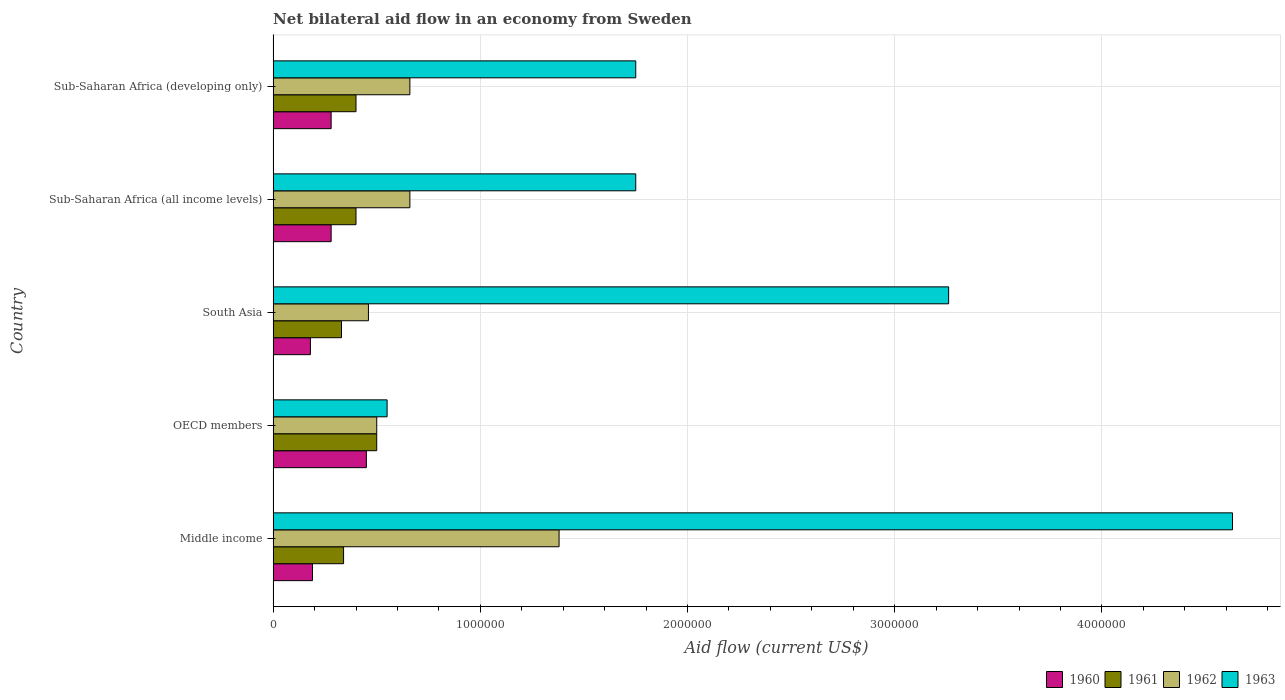Are the number of bars per tick equal to the number of legend labels?
Your response must be concise. Yes. Are the number of bars on each tick of the Y-axis equal?
Give a very brief answer. Yes. How many bars are there on the 2nd tick from the top?
Make the answer very short. 4. How many bars are there on the 2nd tick from the bottom?
Offer a terse response. 4. What is the label of the 3rd group of bars from the top?
Provide a short and direct response. South Asia. In how many cases, is the number of bars for a given country not equal to the number of legend labels?
Offer a very short reply. 0. What is the total net bilateral aid flow in 1962 in the graph?
Provide a short and direct response. 3.66e+06. What is the difference between the net bilateral aid flow in 1962 in South Asia and that in Sub-Saharan Africa (developing only)?
Provide a succinct answer. -2.00e+05. What is the difference between the net bilateral aid flow in 1963 in Sub-Saharan Africa (all income levels) and the net bilateral aid flow in 1960 in South Asia?
Provide a short and direct response. 1.57e+06. What is the average net bilateral aid flow in 1963 per country?
Provide a succinct answer. 2.39e+06. What is the difference between the net bilateral aid flow in 1960 and net bilateral aid flow in 1963 in South Asia?
Provide a succinct answer. -3.08e+06. What is the ratio of the net bilateral aid flow in 1962 in South Asia to that in Sub-Saharan Africa (developing only)?
Provide a succinct answer. 0.7. Is the net bilateral aid flow in 1963 in South Asia less than that in Sub-Saharan Africa (all income levels)?
Offer a very short reply. No. Is the difference between the net bilateral aid flow in 1960 in Sub-Saharan Africa (all income levels) and Sub-Saharan Africa (developing only) greater than the difference between the net bilateral aid flow in 1963 in Sub-Saharan Africa (all income levels) and Sub-Saharan Africa (developing only)?
Make the answer very short. No. What is the difference between the highest and the second highest net bilateral aid flow in 1961?
Offer a terse response. 1.00e+05. Is the sum of the net bilateral aid flow in 1962 in Sub-Saharan Africa (all income levels) and Sub-Saharan Africa (developing only) greater than the maximum net bilateral aid flow in 1960 across all countries?
Offer a terse response. Yes. Is it the case that in every country, the sum of the net bilateral aid flow in 1962 and net bilateral aid flow in 1960 is greater than the sum of net bilateral aid flow in 1961 and net bilateral aid flow in 1963?
Make the answer very short. No. What does the 3rd bar from the bottom in OECD members represents?
Your response must be concise. 1962. Is it the case that in every country, the sum of the net bilateral aid flow in 1960 and net bilateral aid flow in 1962 is greater than the net bilateral aid flow in 1961?
Provide a short and direct response. Yes. Are all the bars in the graph horizontal?
Your response must be concise. Yes. What is the difference between two consecutive major ticks on the X-axis?
Your answer should be very brief. 1.00e+06. Are the values on the major ticks of X-axis written in scientific E-notation?
Keep it short and to the point. No. Does the graph contain any zero values?
Ensure brevity in your answer.  No. Where does the legend appear in the graph?
Ensure brevity in your answer.  Bottom right. What is the title of the graph?
Provide a succinct answer. Net bilateral aid flow in an economy from Sweden. Does "1985" appear as one of the legend labels in the graph?
Provide a succinct answer. No. What is the label or title of the Y-axis?
Your answer should be very brief. Country. What is the Aid flow (current US$) of 1962 in Middle income?
Provide a short and direct response. 1.38e+06. What is the Aid flow (current US$) in 1963 in Middle income?
Offer a very short reply. 4.63e+06. What is the Aid flow (current US$) in 1962 in OECD members?
Keep it short and to the point. 5.00e+05. What is the Aid flow (current US$) in 1963 in South Asia?
Offer a very short reply. 3.26e+06. What is the Aid flow (current US$) of 1961 in Sub-Saharan Africa (all income levels)?
Your answer should be very brief. 4.00e+05. What is the Aid flow (current US$) in 1962 in Sub-Saharan Africa (all income levels)?
Keep it short and to the point. 6.60e+05. What is the Aid flow (current US$) of 1963 in Sub-Saharan Africa (all income levels)?
Provide a short and direct response. 1.75e+06. What is the Aid flow (current US$) in 1960 in Sub-Saharan Africa (developing only)?
Your answer should be very brief. 2.80e+05. What is the Aid flow (current US$) of 1961 in Sub-Saharan Africa (developing only)?
Provide a succinct answer. 4.00e+05. What is the Aid flow (current US$) in 1963 in Sub-Saharan Africa (developing only)?
Provide a succinct answer. 1.75e+06. Across all countries, what is the maximum Aid flow (current US$) in 1962?
Provide a succinct answer. 1.38e+06. Across all countries, what is the maximum Aid flow (current US$) in 1963?
Your answer should be compact. 4.63e+06. Across all countries, what is the minimum Aid flow (current US$) of 1961?
Make the answer very short. 3.30e+05. Across all countries, what is the minimum Aid flow (current US$) of 1962?
Your answer should be compact. 4.60e+05. Across all countries, what is the minimum Aid flow (current US$) in 1963?
Provide a short and direct response. 5.50e+05. What is the total Aid flow (current US$) of 1960 in the graph?
Ensure brevity in your answer.  1.38e+06. What is the total Aid flow (current US$) in 1961 in the graph?
Offer a terse response. 1.97e+06. What is the total Aid flow (current US$) of 1962 in the graph?
Provide a succinct answer. 3.66e+06. What is the total Aid flow (current US$) of 1963 in the graph?
Give a very brief answer. 1.19e+07. What is the difference between the Aid flow (current US$) in 1960 in Middle income and that in OECD members?
Offer a very short reply. -2.60e+05. What is the difference between the Aid flow (current US$) in 1962 in Middle income and that in OECD members?
Provide a short and direct response. 8.80e+05. What is the difference between the Aid flow (current US$) of 1963 in Middle income and that in OECD members?
Offer a terse response. 4.08e+06. What is the difference between the Aid flow (current US$) of 1960 in Middle income and that in South Asia?
Make the answer very short. 10000. What is the difference between the Aid flow (current US$) in 1962 in Middle income and that in South Asia?
Provide a succinct answer. 9.20e+05. What is the difference between the Aid flow (current US$) in 1963 in Middle income and that in South Asia?
Your answer should be very brief. 1.37e+06. What is the difference between the Aid flow (current US$) of 1960 in Middle income and that in Sub-Saharan Africa (all income levels)?
Your answer should be very brief. -9.00e+04. What is the difference between the Aid flow (current US$) in 1962 in Middle income and that in Sub-Saharan Africa (all income levels)?
Your answer should be very brief. 7.20e+05. What is the difference between the Aid flow (current US$) in 1963 in Middle income and that in Sub-Saharan Africa (all income levels)?
Your answer should be compact. 2.88e+06. What is the difference between the Aid flow (current US$) of 1961 in Middle income and that in Sub-Saharan Africa (developing only)?
Offer a terse response. -6.00e+04. What is the difference between the Aid flow (current US$) of 1962 in Middle income and that in Sub-Saharan Africa (developing only)?
Offer a very short reply. 7.20e+05. What is the difference between the Aid flow (current US$) in 1963 in Middle income and that in Sub-Saharan Africa (developing only)?
Provide a short and direct response. 2.88e+06. What is the difference between the Aid flow (current US$) in 1963 in OECD members and that in South Asia?
Offer a terse response. -2.71e+06. What is the difference between the Aid flow (current US$) of 1960 in OECD members and that in Sub-Saharan Africa (all income levels)?
Your response must be concise. 1.70e+05. What is the difference between the Aid flow (current US$) in 1962 in OECD members and that in Sub-Saharan Africa (all income levels)?
Your answer should be very brief. -1.60e+05. What is the difference between the Aid flow (current US$) in 1963 in OECD members and that in Sub-Saharan Africa (all income levels)?
Provide a short and direct response. -1.20e+06. What is the difference between the Aid flow (current US$) of 1961 in OECD members and that in Sub-Saharan Africa (developing only)?
Your answer should be very brief. 1.00e+05. What is the difference between the Aid flow (current US$) of 1962 in OECD members and that in Sub-Saharan Africa (developing only)?
Your answer should be very brief. -1.60e+05. What is the difference between the Aid flow (current US$) of 1963 in OECD members and that in Sub-Saharan Africa (developing only)?
Offer a terse response. -1.20e+06. What is the difference between the Aid flow (current US$) in 1960 in South Asia and that in Sub-Saharan Africa (all income levels)?
Your answer should be very brief. -1.00e+05. What is the difference between the Aid flow (current US$) of 1961 in South Asia and that in Sub-Saharan Africa (all income levels)?
Give a very brief answer. -7.00e+04. What is the difference between the Aid flow (current US$) of 1962 in South Asia and that in Sub-Saharan Africa (all income levels)?
Give a very brief answer. -2.00e+05. What is the difference between the Aid flow (current US$) of 1963 in South Asia and that in Sub-Saharan Africa (all income levels)?
Make the answer very short. 1.51e+06. What is the difference between the Aid flow (current US$) in 1961 in South Asia and that in Sub-Saharan Africa (developing only)?
Offer a very short reply. -7.00e+04. What is the difference between the Aid flow (current US$) of 1962 in South Asia and that in Sub-Saharan Africa (developing only)?
Provide a succinct answer. -2.00e+05. What is the difference between the Aid flow (current US$) of 1963 in South Asia and that in Sub-Saharan Africa (developing only)?
Provide a short and direct response. 1.51e+06. What is the difference between the Aid flow (current US$) in 1962 in Sub-Saharan Africa (all income levels) and that in Sub-Saharan Africa (developing only)?
Your response must be concise. 0. What is the difference between the Aid flow (current US$) in 1960 in Middle income and the Aid flow (current US$) in 1961 in OECD members?
Give a very brief answer. -3.10e+05. What is the difference between the Aid flow (current US$) of 1960 in Middle income and the Aid flow (current US$) of 1962 in OECD members?
Provide a short and direct response. -3.10e+05. What is the difference between the Aid flow (current US$) in 1960 in Middle income and the Aid flow (current US$) in 1963 in OECD members?
Your answer should be compact. -3.60e+05. What is the difference between the Aid flow (current US$) in 1961 in Middle income and the Aid flow (current US$) in 1962 in OECD members?
Your answer should be compact. -1.60e+05. What is the difference between the Aid flow (current US$) of 1962 in Middle income and the Aid flow (current US$) of 1963 in OECD members?
Offer a very short reply. 8.30e+05. What is the difference between the Aid flow (current US$) in 1960 in Middle income and the Aid flow (current US$) in 1961 in South Asia?
Your answer should be compact. -1.40e+05. What is the difference between the Aid flow (current US$) in 1960 in Middle income and the Aid flow (current US$) in 1962 in South Asia?
Your answer should be compact. -2.70e+05. What is the difference between the Aid flow (current US$) of 1960 in Middle income and the Aid flow (current US$) of 1963 in South Asia?
Provide a succinct answer. -3.07e+06. What is the difference between the Aid flow (current US$) in 1961 in Middle income and the Aid flow (current US$) in 1962 in South Asia?
Give a very brief answer. -1.20e+05. What is the difference between the Aid flow (current US$) in 1961 in Middle income and the Aid flow (current US$) in 1963 in South Asia?
Your answer should be compact. -2.92e+06. What is the difference between the Aid flow (current US$) in 1962 in Middle income and the Aid flow (current US$) in 1963 in South Asia?
Make the answer very short. -1.88e+06. What is the difference between the Aid flow (current US$) in 1960 in Middle income and the Aid flow (current US$) in 1962 in Sub-Saharan Africa (all income levels)?
Ensure brevity in your answer.  -4.70e+05. What is the difference between the Aid flow (current US$) of 1960 in Middle income and the Aid flow (current US$) of 1963 in Sub-Saharan Africa (all income levels)?
Provide a short and direct response. -1.56e+06. What is the difference between the Aid flow (current US$) in 1961 in Middle income and the Aid flow (current US$) in 1962 in Sub-Saharan Africa (all income levels)?
Give a very brief answer. -3.20e+05. What is the difference between the Aid flow (current US$) in 1961 in Middle income and the Aid flow (current US$) in 1963 in Sub-Saharan Africa (all income levels)?
Ensure brevity in your answer.  -1.41e+06. What is the difference between the Aid flow (current US$) of 1962 in Middle income and the Aid flow (current US$) of 1963 in Sub-Saharan Africa (all income levels)?
Make the answer very short. -3.70e+05. What is the difference between the Aid flow (current US$) of 1960 in Middle income and the Aid flow (current US$) of 1962 in Sub-Saharan Africa (developing only)?
Your answer should be very brief. -4.70e+05. What is the difference between the Aid flow (current US$) in 1960 in Middle income and the Aid flow (current US$) in 1963 in Sub-Saharan Africa (developing only)?
Make the answer very short. -1.56e+06. What is the difference between the Aid flow (current US$) of 1961 in Middle income and the Aid flow (current US$) of 1962 in Sub-Saharan Africa (developing only)?
Make the answer very short. -3.20e+05. What is the difference between the Aid flow (current US$) in 1961 in Middle income and the Aid flow (current US$) in 1963 in Sub-Saharan Africa (developing only)?
Provide a short and direct response. -1.41e+06. What is the difference between the Aid flow (current US$) in 1962 in Middle income and the Aid flow (current US$) in 1963 in Sub-Saharan Africa (developing only)?
Provide a short and direct response. -3.70e+05. What is the difference between the Aid flow (current US$) in 1960 in OECD members and the Aid flow (current US$) in 1963 in South Asia?
Make the answer very short. -2.81e+06. What is the difference between the Aid flow (current US$) of 1961 in OECD members and the Aid flow (current US$) of 1963 in South Asia?
Ensure brevity in your answer.  -2.76e+06. What is the difference between the Aid flow (current US$) of 1962 in OECD members and the Aid flow (current US$) of 1963 in South Asia?
Your answer should be compact. -2.76e+06. What is the difference between the Aid flow (current US$) in 1960 in OECD members and the Aid flow (current US$) in 1963 in Sub-Saharan Africa (all income levels)?
Give a very brief answer. -1.30e+06. What is the difference between the Aid flow (current US$) of 1961 in OECD members and the Aid flow (current US$) of 1962 in Sub-Saharan Africa (all income levels)?
Your answer should be compact. -1.60e+05. What is the difference between the Aid flow (current US$) of 1961 in OECD members and the Aid flow (current US$) of 1963 in Sub-Saharan Africa (all income levels)?
Make the answer very short. -1.25e+06. What is the difference between the Aid flow (current US$) of 1962 in OECD members and the Aid flow (current US$) of 1963 in Sub-Saharan Africa (all income levels)?
Provide a succinct answer. -1.25e+06. What is the difference between the Aid flow (current US$) of 1960 in OECD members and the Aid flow (current US$) of 1961 in Sub-Saharan Africa (developing only)?
Your answer should be very brief. 5.00e+04. What is the difference between the Aid flow (current US$) of 1960 in OECD members and the Aid flow (current US$) of 1963 in Sub-Saharan Africa (developing only)?
Offer a terse response. -1.30e+06. What is the difference between the Aid flow (current US$) of 1961 in OECD members and the Aid flow (current US$) of 1962 in Sub-Saharan Africa (developing only)?
Ensure brevity in your answer.  -1.60e+05. What is the difference between the Aid flow (current US$) in 1961 in OECD members and the Aid flow (current US$) in 1963 in Sub-Saharan Africa (developing only)?
Your answer should be very brief. -1.25e+06. What is the difference between the Aid flow (current US$) in 1962 in OECD members and the Aid flow (current US$) in 1963 in Sub-Saharan Africa (developing only)?
Provide a short and direct response. -1.25e+06. What is the difference between the Aid flow (current US$) in 1960 in South Asia and the Aid flow (current US$) in 1962 in Sub-Saharan Africa (all income levels)?
Offer a terse response. -4.80e+05. What is the difference between the Aid flow (current US$) of 1960 in South Asia and the Aid flow (current US$) of 1963 in Sub-Saharan Africa (all income levels)?
Ensure brevity in your answer.  -1.57e+06. What is the difference between the Aid flow (current US$) of 1961 in South Asia and the Aid flow (current US$) of 1962 in Sub-Saharan Africa (all income levels)?
Provide a short and direct response. -3.30e+05. What is the difference between the Aid flow (current US$) of 1961 in South Asia and the Aid flow (current US$) of 1963 in Sub-Saharan Africa (all income levels)?
Make the answer very short. -1.42e+06. What is the difference between the Aid flow (current US$) in 1962 in South Asia and the Aid flow (current US$) in 1963 in Sub-Saharan Africa (all income levels)?
Your answer should be very brief. -1.29e+06. What is the difference between the Aid flow (current US$) of 1960 in South Asia and the Aid flow (current US$) of 1961 in Sub-Saharan Africa (developing only)?
Offer a terse response. -2.20e+05. What is the difference between the Aid flow (current US$) of 1960 in South Asia and the Aid flow (current US$) of 1962 in Sub-Saharan Africa (developing only)?
Your response must be concise. -4.80e+05. What is the difference between the Aid flow (current US$) in 1960 in South Asia and the Aid flow (current US$) in 1963 in Sub-Saharan Africa (developing only)?
Provide a succinct answer. -1.57e+06. What is the difference between the Aid flow (current US$) in 1961 in South Asia and the Aid flow (current US$) in 1962 in Sub-Saharan Africa (developing only)?
Make the answer very short. -3.30e+05. What is the difference between the Aid flow (current US$) in 1961 in South Asia and the Aid flow (current US$) in 1963 in Sub-Saharan Africa (developing only)?
Give a very brief answer. -1.42e+06. What is the difference between the Aid flow (current US$) in 1962 in South Asia and the Aid flow (current US$) in 1963 in Sub-Saharan Africa (developing only)?
Offer a terse response. -1.29e+06. What is the difference between the Aid flow (current US$) of 1960 in Sub-Saharan Africa (all income levels) and the Aid flow (current US$) of 1961 in Sub-Saharan Africa (developing only)?
Provide a succinct answer. -1.20e+05. What is the difference between the Aid flow (current US$) of 1960 in Sub-Saharan Africa (all income levels) and the Aid flow (current US$) of 1962 in Sub-Saharan Africa (developing only)?
Provide a short and direct response. -3.80e+05. What is the difference between the Aid flow (current US$) of 1960 in Sub-Saharan Africa (all income levels) and the Aid flow (current US$) of 1963 in Sub-Saharan Africa (developing only)?
Your answer should be compact. -1.47e+06. What is the difference between the Aid flow (current US$) in 1961 in Sub-Saharan Africa (all income levels) and the Aid flow (current US$) in 1963 in Sub-Saharan Africa (developing only)?
Give a very brief answer. -1.35e+06. What is the difference between the Aid flow (current US$) in 1962 in Sub-Saharan Africa (all income levels) and the Aid flow (current US$) in 1963 in Sub-Saharan Africa (developing only)?
Ensure brevity in your answer.  -1.09e+06. What is the average Aid flow (current US$) in 1960 per country?
Provide a short and direct response. 2.76e+05. What is the average Aid flow (current US$) in 1961 per country?
Ensure brevity in your answer.  3.94e+05. What is the average Aid flow (current US$) in 1962 per country?
Give a very brief answer. 7.32e+05. What is the average Aid flow (current US$) of 1963 per country?
Provide a succinct answer. 2.39e+06. What is the difference between the Aid flow (current US$) in 1960 and Aid flow (current US$) in 1962 in Middle income?
Give a very brief answer. -1.19e+06. What is the difference between the Aid flow (current US$) in 1960 and Aid flow (current US$) in 1963 in Middle income?
Keep it short and to the point. -4.44e+06. What is the difference between the Aid flow (current US$) of 1961 and Aid flow (current US$) of 1962 in Middle income?
Give a very brief answer. -1.04e+06. What is the difference between the Aid flow (current US$) in 1961 and Aid flow (current US$) in 1963 in Middle income?
Make the answer very short. -4.29e+06. What is the difference between the Aid flow (current US$) in 1962 and Aid flow (current US$) in 1963 in Middle income?
Offer a very short reply. -3.25e+06. What is the difference between the Aid flow (current US$) in 1960 and Aid flow (current US$) in 1963 in OECD members?
Provide a succinct answer. -1.00e+05. What is the difference between the Aid flow (current US$) of 1961 and Aid flow (current US$) of 1962 in OECD members?
Provide a short and direct response. 0. What is the difference between the Aid flow (current US$) of 1961 and Aid flow (current US$) of 1963 in OECD members?
Give a very brief answer. -5.00e+04. What is the difference between the Aid flow (current US$) of 1960 and Aid flow (current US$) of 1962 in South Asia?
Keep it short and to the point. -2.80e+05. What is the difference between the Aid flow (current US$) in 1960 and Aid flow (current US$) in 1963 in South Asia?
Provide a short and direct response. -3.08e+06. What is the difference between the Aid flow (current US$) in 1961 and Aid flow (current US$) in 1962 in South Asia?
Offer a terse response. -1.30e+05. What is the difference between the Aid flow (current US$) of 1961 and Aid flow (current US$) of 1963 in South Asia?
Give a very brief answer. -2.93e+06. What is the difference between the Aid flow (current US$) of 1962 and Aid flow (current US$) of 1963 in South Asia?
Provide a succinct answer. -2.80e+06. What is the difference between the Aid flow (current US$) in 1960 and Aid flow (current US$) in 1961 in Sub-Saharan Africa (all income levels)?
Ensure brevity in your answer.  -1.20e+05. What is the difference between the Aid flow (current US$) of 1960 and Aid flow (current US$) of 1962 in Sub-Saharan Africa (all income levels)?
Your answer should be compact. -3.80e+05. What is the difference between the Aid flow (current US$) in 1960 and Aid flow (current US$) in 1963 in Sub-Saharan Africa (all income levels)?
Your answer should be compact. -1.47e+06. What is the difference between the Aid flow (current US$) of 1961 and Aid flow (current US$) of 1963 in Sub-Saharan Africa (all income levels)?
Your answer should be compact. -1.35e+06. What is the difference between the Aid flow (current US$) in 1962 and Aid flow (current US$) in 1963 in Sub-Saharan Africa (all income levels)?
Make the answer very short. -1.09e+06. What is the difference between the Aid flow (current US$) in 1960 and Aid flow (current US$) in 1961 in Sub-Saharan Africa (developing only)?
Your answer should be very brief. -1.20e+05. What is the difference between the Aid flow (current US$) in 1960 and Aid flow (current US$) in 1962 in Sub-Saharan Africa (developing only)?
Offer a terse response. -3.80e+05. What is the difference between the Aid flow (current US$) of 1960 and Aid flow (current US$) of 1963 in Sub-Saharan Africa (developing only)?
Give a very brief answer. -1.47e+06. What is the difference between the Aid flow (current US$) in 1961 and Aid flow (current US$) in 1963 in Sub-Saharan Africa (developing only)?
Provide a short and direct response. -1.35e+06. What is the difference between the Aid flow (current US$) of 1962 and Aid flow (current US$) of 1963 in Sub-Saharan Africa (developing only)?
Provide a short and direct response. -1.09e+06. What is the ratio of the Aid flow (current US$) in 1960 in Middle income to that in OECD members?
Provide a succinct answer. 0.42. What is the ratio of the Aid flow (current US$) in 1961 in Middle income to that in OECD members?
Keep it short and to the point. 0.68. What is the ratio of the Aid flow (current US$) of 1962 in Middle income to that in OECD members?
Make the answer very short. 2.76. What is the ratio of the Aid flow (current US$) of 1963 in Middle income to that in OECD members?
Your answer should be compact. 8.42. What is the ratio of the Aid flow (current US$) in 1960 in Middle income to that in South Asia?
Give a very brief answer. 1.06. What is the ratio of the Aid flow (current US$) of 1961 in Middle income to that in South Asia?
Your answer should be very brief. 1.03. What is the ratio of the Aid flow (current US$) of 1963 in Middle income to that in South Asia?
Keep it short and to the point. 1.42. What is the ratio of the Aid flow (current US$) in 1960 in Middle income to that in Sub-Saharan Africa (all income levels)?
Your response must be concise. 0.68. What is the ratio of the Aid flow (current US$) of 1962 in Middle income to that in Sub-Saharan Africa (all income levels)?
Provide a succinct answer. 2.09. What is the ratio of the Aid flow (current US$) of 1963 in Middle income to that in Sub-Saharan Africa (all income levels)?
Offer a terse response. 2.65. What is the ratio of the Aid flow (current US$) in 1960 in Middle income to that in Sub-Saharan Africa (developing only)?
Ensure brevity in your answer.  0.68. What is the ratio of the Aid flow (current US$) of 1961 in Middle income to that in Sub-Saharan Africa (developing only)?
Your answer should be very brief. 0.85. What is the ratio of the Aid flow (current US$) in 1962 in Middle income to that in Sub-Saharan Africa (developing only)?
Your answer should be compact. 2.09. What is the ratio of the Aid flow (current US$) of 1963 in Middle income to that in Sub-Saharan Africa (developing only)?
Make the answer very short. 2.65. What is the ratio of the Aid flow (current US$) in 1960 in OECD members to that in South Asia?
Keep it short and to the point. 2.5. What is the ratio of the Aid flow (current US$) of 1961 in OECD members to that in South Asia?
Make the answer very short. 1.52. What is the ratio of the Aid flow (current US$) of 1962 in OECD members to that in South Asia?
Make the answer very short. 1.09. What is the ratio of the Aid flow (current US$) of 1963 in OECD members to that in South Asia?
Your answer should be compact. 0.17. What is the ratio of the Aid flow (current US$) in 1960 in OECD members to that in Sub-Saharan Africa (all income levels)?
Offer a very short reply. 1.61. What is the ratio of the Aid flow (current US$) of 1962 in OECD members to that in Sub-Saharan Africa (all income levels)?
Your answer should be compact. 0.76. What is the ratio of the Aid flow (current US$) in 1963 in OECD members to that in Sub-Saharan Africa (all income levels)?
Keep it short and to the point. 0.31. What is the ratio of the Aid flow (current US$) of 1960 in OECD members to that in Sub-Saharan Africa (developing only)?
Your answer should be compact. 1.61. What is the ratio of the Aid flow (current US$) of 1961 in OECD members to that in Sub-Saharan Africa (developing only)?
Give a very brief answer. 1.25. What is the ratio of the Aid flow (current US$) of 1962 in OECD members to that in Sub-Saharan Africa (developing only)?
Your answer should be compact. 0.76. What is the ratio of the Aid flow (current US$) of 1963 in OECD members to that in Sub-Saharan Africa (developing only)?
Provide a short and direct response. 0.31. What is the ratio of the Aid flow (current US$) of 1960 in South Asia to that in Sub-Saharan Africa (all income levels)?
Your answer should be very brief. 0.64. What is the ratio of the Aid flow (current US$) in 1961 in South Asia to that in Sub-Saharan Africa (all income levels)?
Your answer should be compact. 0.82. What is the ratio of the Aid flow (current US$) of 1962 in South Asia to that in Sub-Saharan Africa (all income levels)?
Your answer should be compact. 0.7. What is the ratio of the Aid flow (current US$) of 1963 in South Asia to that in Sub-Saharan Africa (all income levels)?
Keep it short and to the point. 1.86. What is the ratio of the Aid flow (current US$) in 1960 in South Asia to that in Sub-Saharan Africa (developing only)?
Offer a very short reply. 0.64. What is the ratio of the Aid flow (current US$) of 1961 in South Asia to that in Sub-Saharan Africa (developing only)?
Offer a terse response. 0.82. What is the ratio of the Aid flow (current US$) in 1962 in South Asia to that in Sub-Saharan Africa (developing only)?
Provide a short and direct response. 0.7. What is the ratio of the Aid flow (current US$) in 1963 in South Asia to that in Sub-Saharan Africa (developing only)?
Your answer should be very brief. 1.86. What is the ratio of the Aid flow (current US$) of 1961 in Sub-Saharan Africa (all income levels) to that in Sub-Saharan Africa (developing only)?
Provide a succinct answer. 1. What is the ratio of the Aid flow (current US$) of 1962 in Sub-Saharan Africa (all income levels) to that in Sub-Saharan Africa (developing only)?
Offer a terse response. 1. What is the ratio of the Aid flow (current US$) in 1963 in Sub-Saharan Africa (all income levels) to that in Sub-Saharan Africa (developing only)?
Ensure brevity in your answer.  1. What is the difference between the highest and the second highest Aid flow (current US$) in 1960?
Provide a succinct answer. 1.70e+05. What is the difference between the highest and the second highest Aid flow (current US$) of 1961?
Your answer should be very brief. 1.00e+05. What is the difference between the highest and the second highest Aid flow (current US$) of 1962?
Keep it short and to the point. 7.20e+05. What is the difference between the highest and the second highest Aid flow (current US$) of 1963?
Your answer should be compact. 1.37e+06. What is the difference between the highest and the lowest Aid flow (current US$) of 1962?
Your answer should be compact. 9.20e+05. What is the difference between the highest and the lowest Aid flow (current US$) in 1963?
Offer a very short reply. 4.08e+06. 